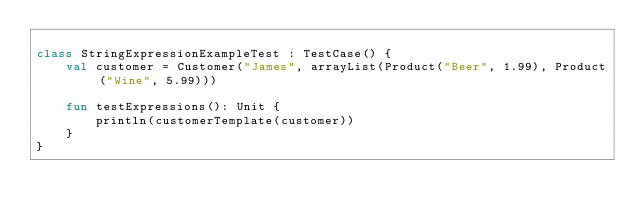<code> <loc_0><loc_0><loc_500><loc_500><_Kotlin_>
class StringExpressionExampleTest : TestCase() {
    val customer = Customer("James", arrayList(Product("Beer", 1.99), Product("Wine", 5.99)))

    fun testExpressions(): Unit {
        println(customerTemplate(customer))
    }
}</code> 